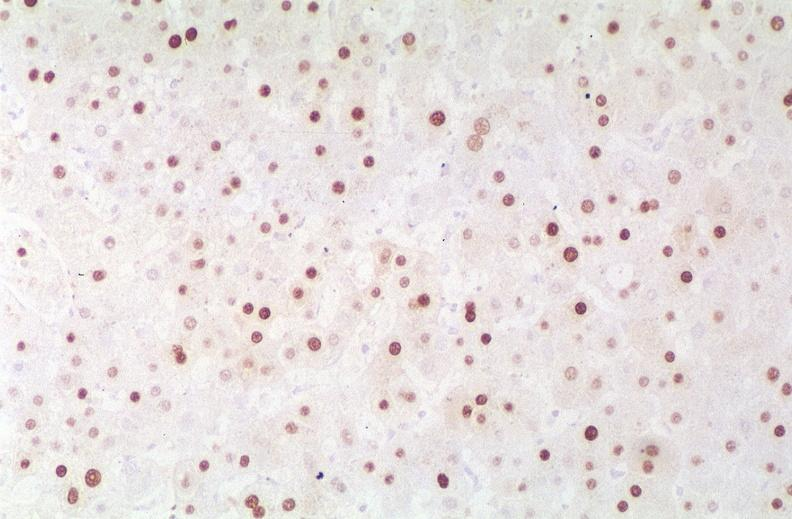s mucoepidermoid carcinoma present?
Answer the question using a single word or phrase. No 